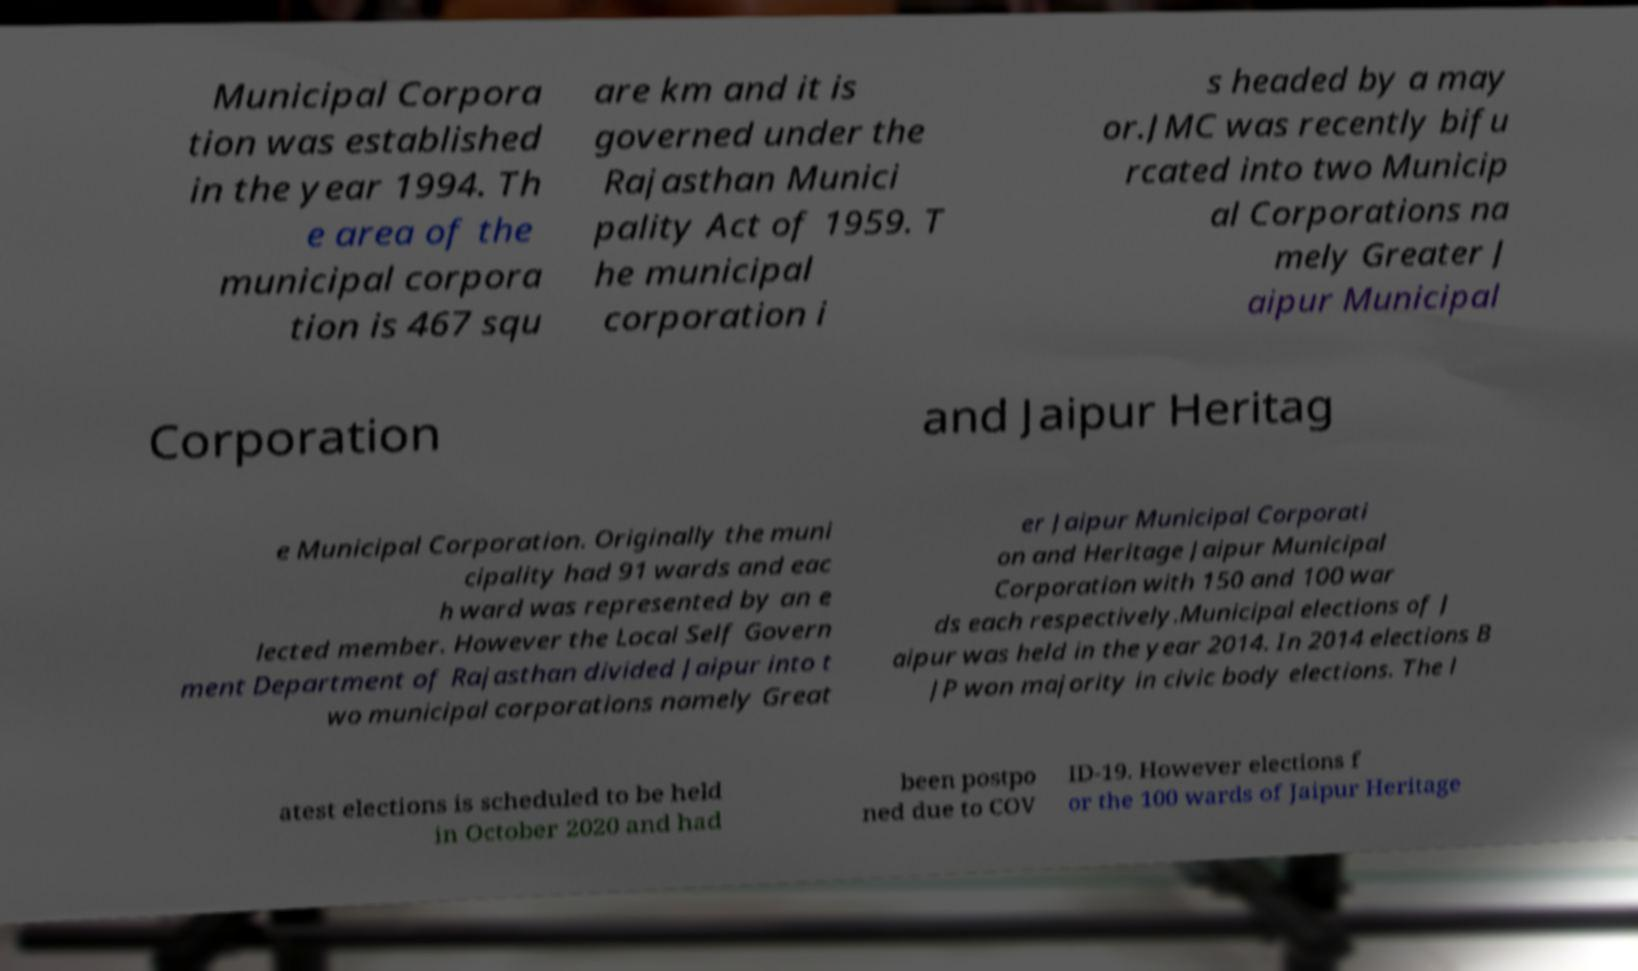For documentation purposes, I need the text within this image transcribed. Could you provide that? Municipal Corpora tion was established in the year 1994. Th e area of the municipal corpora tion is 467 squ are km and it is governed under the Rajasthan Munici pality Act of 1959. T he municipal corporation i s headed by a may or.JMC was recently bifu rcated into two Municip al Corporations na mely Greater J aipur Municipal Corporation and Jaipur Heritag e Municipal Corporation. Originally the muni cipality had 91 wards and eac h ward was represented by an e lected member. However the Local Self Govern ment Department of Rajasthan divided Jaipur into t wo municipal corporations namely Great er Jaipur Municipal Corporati on and Heritage Jaipur Municipal Corporation with 150 and 100 war ds each respectively.Municipal elections of J aipur was held in the year 2014. In 2014 elections B JP won majority in civic body elections. The l atest elections is scheduled to be held in October 2020 and had been postpo ned due to COV ID-19. However elections f or the 100 wards of Jaipur Heritage 